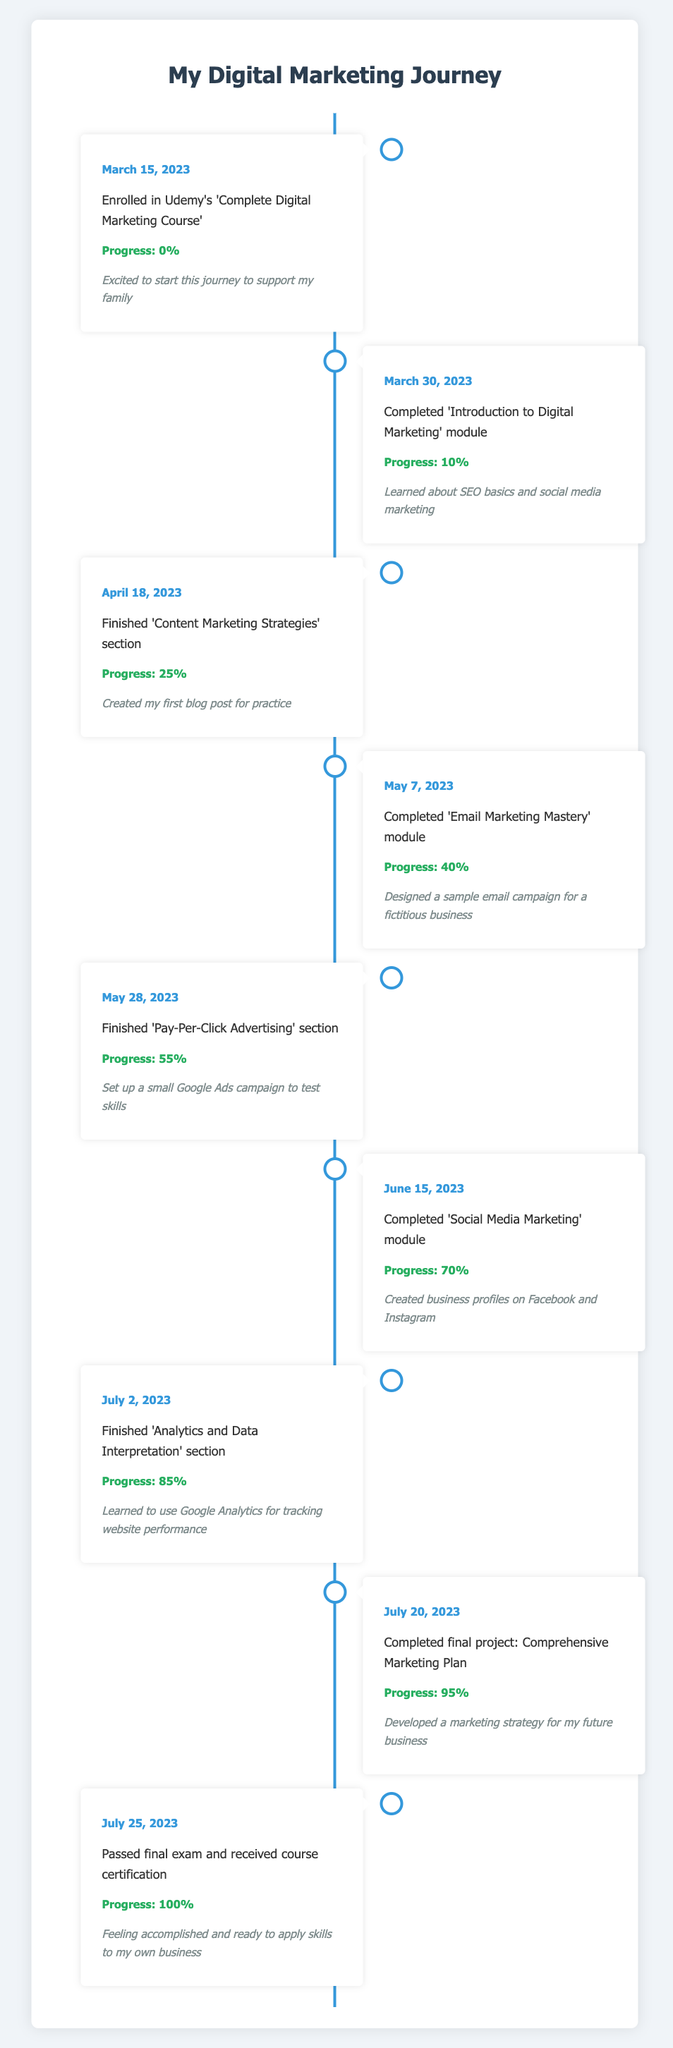What was the date when the course was completed? According to the table, the final event indicating course completion happened on July 25, 2023, when the final exam was passed, and certification was received.
Answer: July 25, 2023 What progress percentage was achieved after finishing the 'Email Marketing Mastery' module? The table indicates that after completing the 'Email Marketing Mastery' module on May 7, 2023, the progress percentage was recorded at 40%.
Answer: 40% Did the individual create any social media profiles during the course? Yes, the notes for the event on June 15, 2023, state that business profiles on Facebook and Instagram were created.
Answer: Yes What was the total progress percentage increase from enrollment to receiving the course certification? To find the total progress increase, we subtract the progress at enrollment (0%) from the progress at certification (100%). Thus, 100% - 0% = 100%.
Answer: 100% Which module had the highest progress percentage when completed? By examining the table, the 'Comprehensive Marketing Plan' final project, completed on July 20, 2023, had a progress percentage of 95%, which is the highest recorded before certification.
Answer: Comprehensive Marketing Plan How many events mentioned in the timeline resulted in a progress increase of at least 15%? The events with a progress increase of at least 15% are: 'Content Marketing Strategies' (from 10% to 25%), 'Email Marketing Mastery' (from 25% to 40%), 'Pay-Per-Click Advertising' (from 40% to 55%), 'Social Media Marketing' (from 55% to 70%), and 'Analytics and Data Interpretation' (from 70% to 85%). In total, 5 events had at least a 15% increase.
Answer: 5 Was there any module where the individual created a practical project during the course? Yes, the individual mentioned creating a sample email campaign for a fictitious business during the 'Email Marketing Mastery' module, and also created a blog post in the 'Content Marketing Strategies' section.
Answer: Yes What was the direct progress after completing the 'Pay-Per-Click Advertising' section? The progress after finishing the 'Pay-Per-Click Advertising' section on May 28, 2023, is noted at 55%.
Answer: 55% On which date was the individual feeling excited to start the course? The individual expressed excitement to start their journey on March 15, 2023, the date of enrollment in the course.
Answer: March 15, 2023 